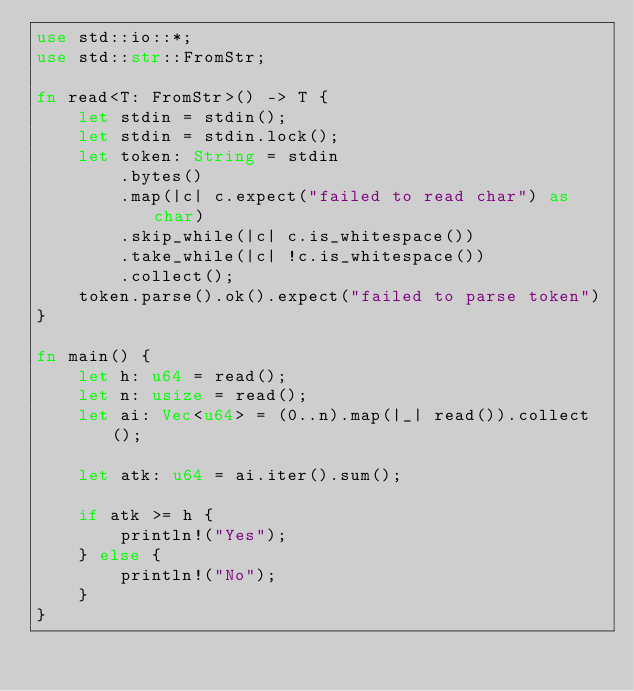Convert code to text. <code><loc_0><loc_0><loc_500><loc_500><_Rust_>use std::io::*;
use std::str::FromStr;

fn read<T: FromStr>() -> T {
    let stdin = stdin();
    let stdin = stdin.lock();
    let token: String = stdin
        .bytes()
        .map(|c| c.expect("failed to read char") as char) 
        .skip_while(|c| c.is_whitespace())
        .take_while(|c| !c.is_whitespace())
        .collect();
    token.parse().ok().expect("failed to parse token")
}

fn main() {
    let h: u64 = read();
    let n: usize = read();
    let ai: Vec<u64> = (0..n).map(|_| read()).collect();

    let atk: u64 = ai.iter().sum();

    if atk >= h {
        println!("Yes");
    } else {
        println!("No");
    }    
}
</code> 